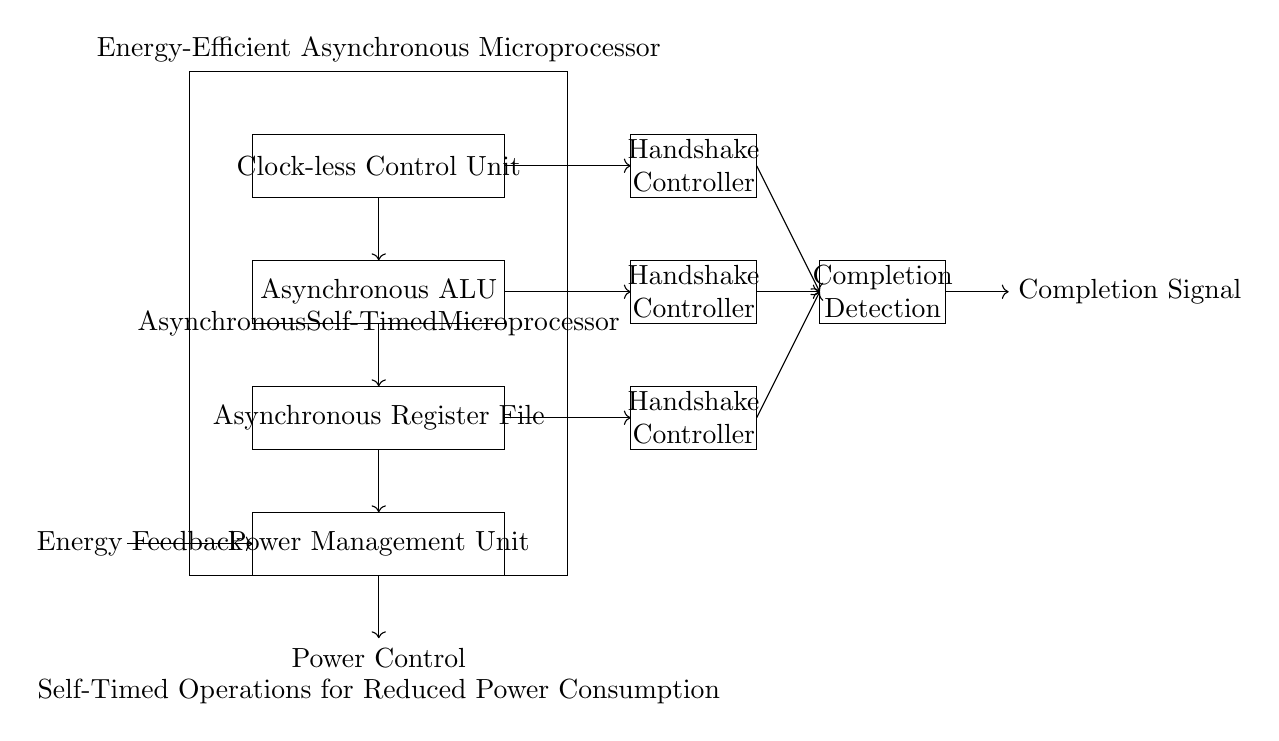What is the main component of the circuit? The main component, as indicated by the largest rectangle, is the Asynchronous Self-Timed Microprocessor.
Answer: Asynchronous Self-Timed Microprocessor How many handshake controllers are present? There are three handshake controllers visible in the circuit diagram, each located at different heights within the microprocessor block.
Answer: Three What does the rectangle labeled "Completion Detection" represent? This rectangle indicates the subsystem responsible for detecting when a computational task is finished, crucial for managing data flow effectively in asynchronous circuits.
Answer: Completion Detection What is the purpose of the Power Management Unit? The Power Management Unit manages energy consumption and optimizes power usage, ensuring that the microprocessor operates efficiently while minimizing energy waste.
Answer: Power Management Unit Which element in the circuit facilitates communication between the ALU and the handshake controller? The arrows in the diagram indicate that the asynchronous ALU communicates directly with the handshake controller, allowing for synchronization of operations without a clock signal.
Answer: Handshake Controller What role does "Energy Feedback" play in this circuit? Energy Feedback is critical as it represents a system component that provides information on energy usage back to the microprocessor, allowing for adjustments in power management based on current needs.
Answer: Energy Feedback How does the circuit achieve energy efficiency? The energy efficiency arises from the asynchronous architecture, which eliminates the need for a global clock, allowing circuits to operate independently and in a self-timed manner, responding only when necessary.
Answer: Self-Timed Operations 